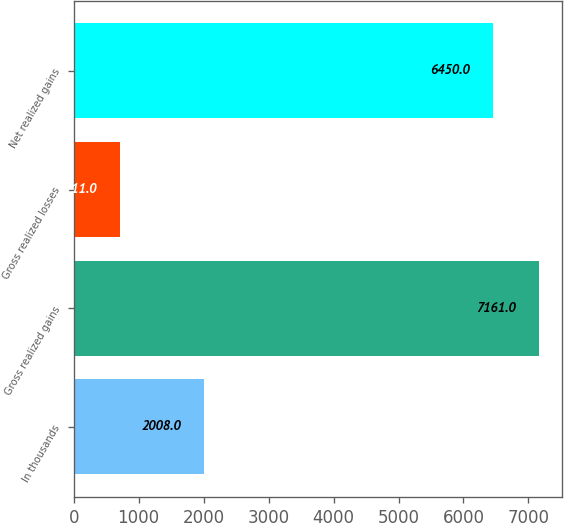Convert chart. <chart><loc_0><loc_0><loc_500><loc_500><bar_chart><fcel>In thousands<fcel>Gross realized gains<fcel>Gross realized losses<fcel>Net realized gains<nl><fcel>2008<fcel>7161<fcel>711<fcel>6450<nl></chart> 